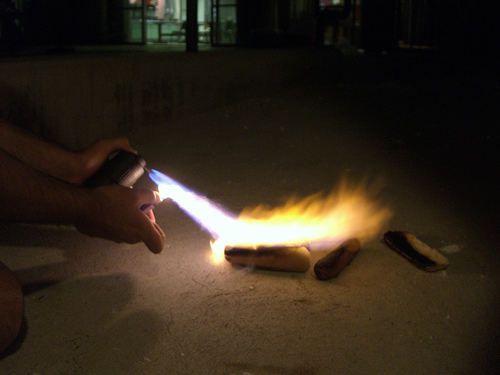<image>
Is there a fire on the bread? Yes. Looking at the image, I can see the fire is positioned on top of the bread, with the bread providing support. 